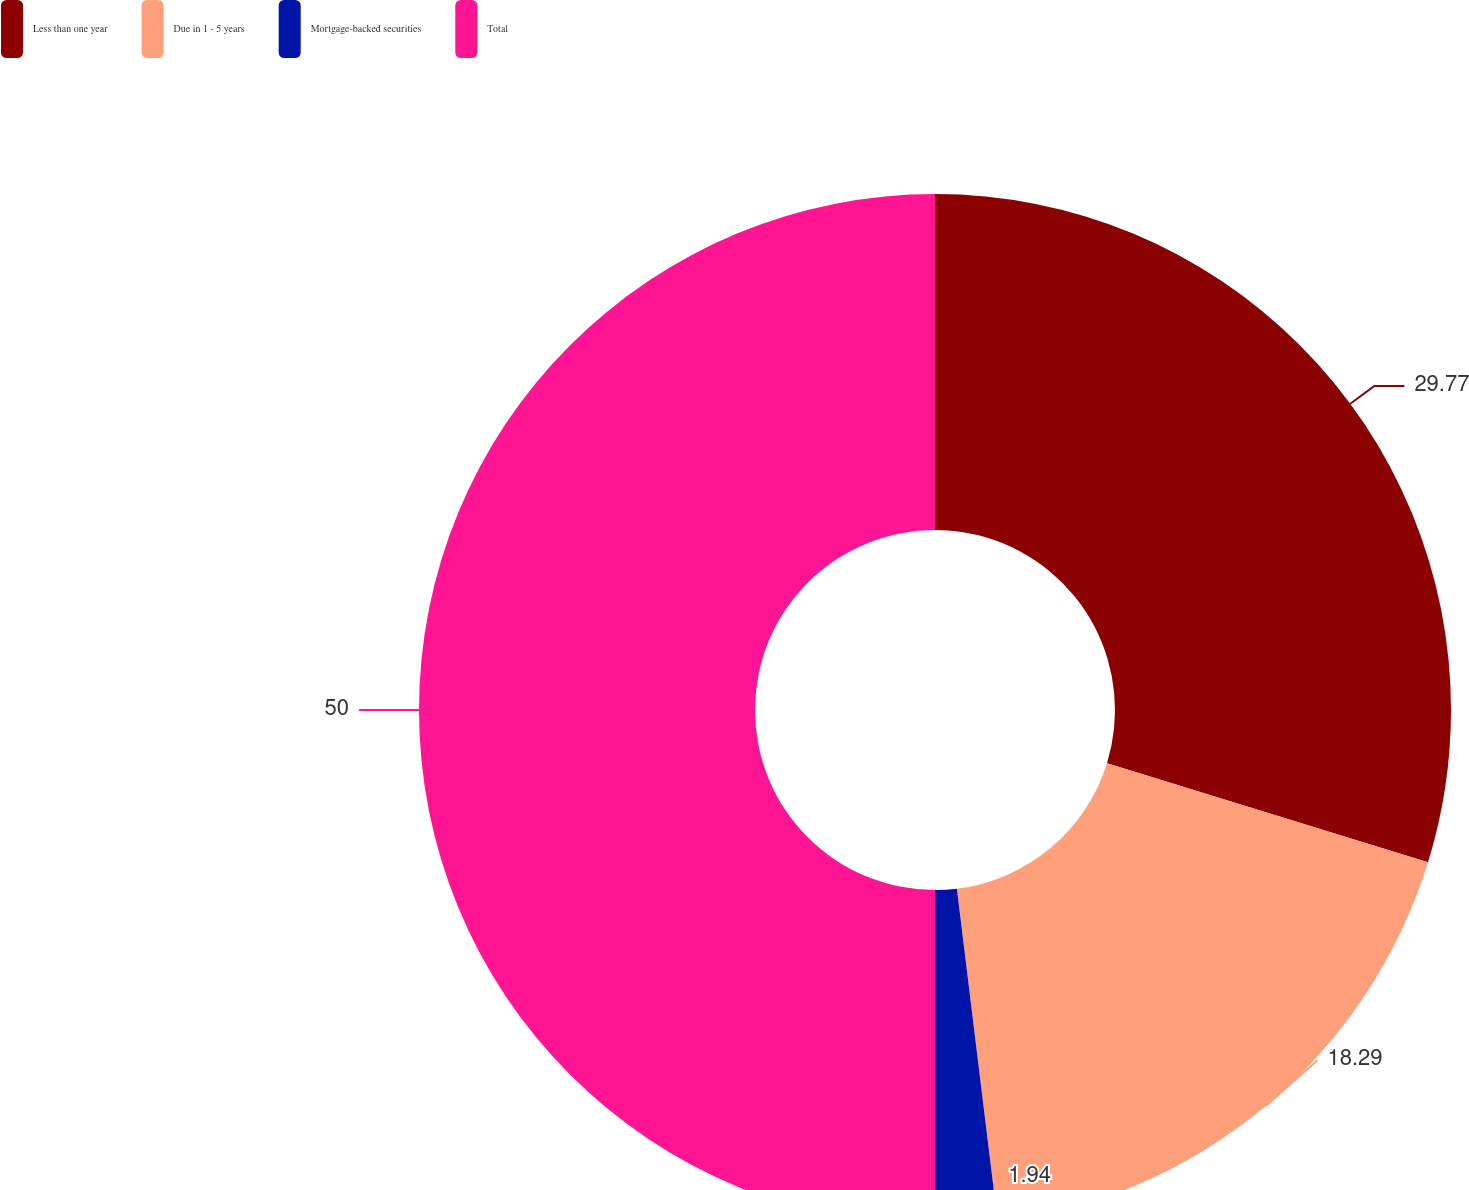<chart> <loc_0><loc_0><loc_500><loc_500><pie_chart><fcel>Less than one year<fcel>Due in 1 - 5 years<fcel>Mortgage-backed securities<fcel>Total<nl><fcel>29.77%<fcel>18.29%<fcel>1.94%<fcel>50.0%<nl></chart> 